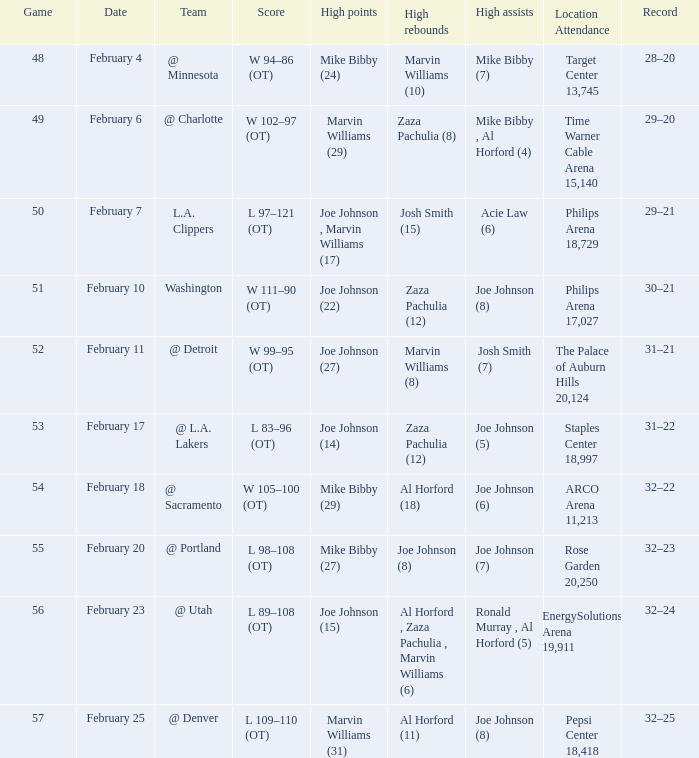Who made high assists on february 4 Mike Bibby (7). 